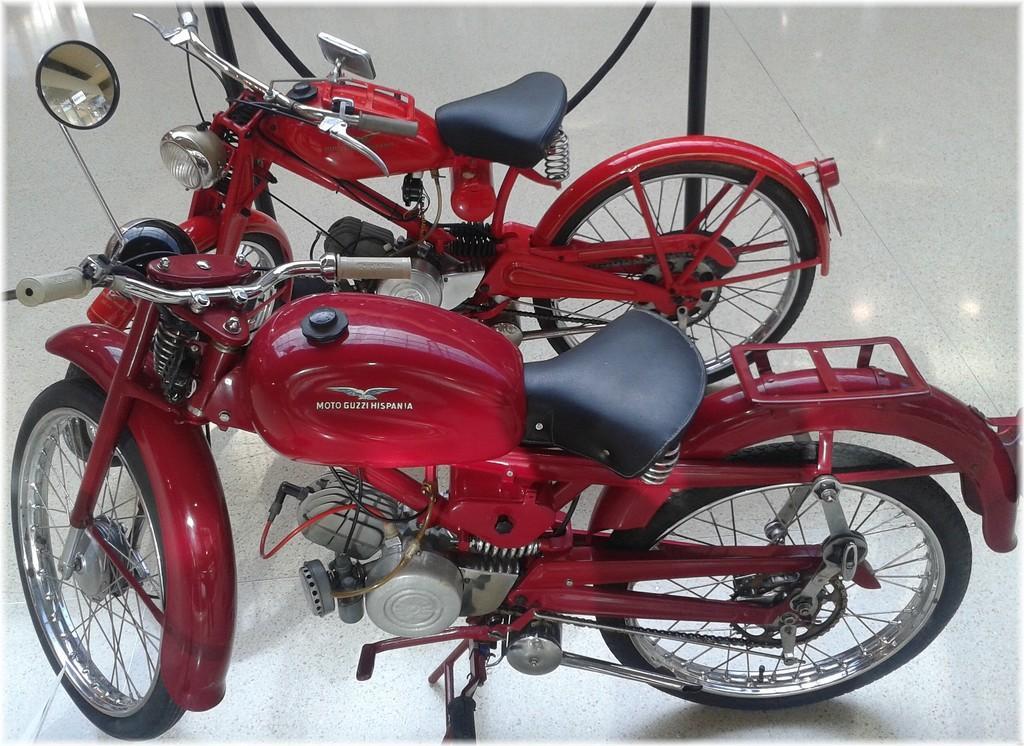Can you describe this image briefly? This image is taken indoors. At the bottom of the image there is a floor. In the middle of the image two bikes are parked on the floor. Those bikes are red in color. 